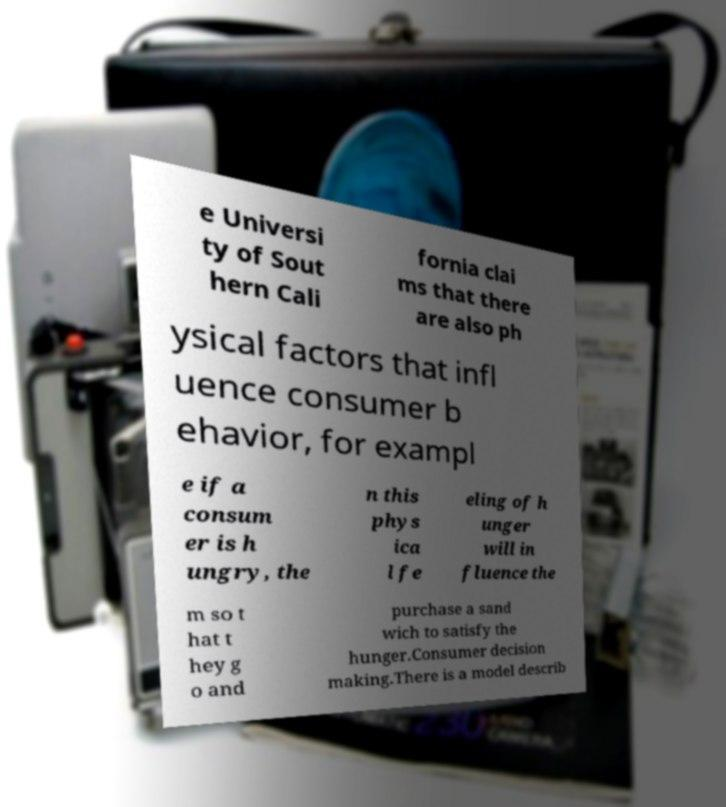Could you extract and type out the text from this image? e Universi ty of Sout hern Cali fornia clai ms that there are also ph ysical factors that infl uence consumer b ehavior, for exampl e if a consum er is h ungry, the n this phys ica l fe eling of h unger will in fluence the m so t hat t hey g o and purchase a sand wich to satisfy the hunger.Consumer decision making.There is a model describ 